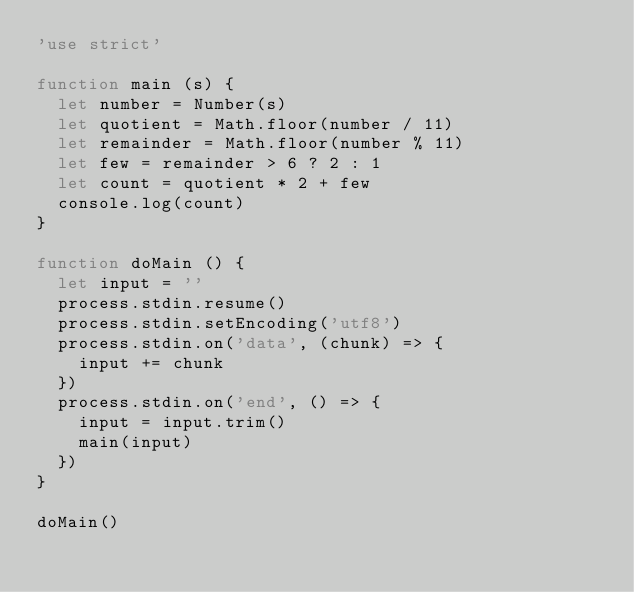Convert code to text. <code><loc_0><loc_0><loc_500><loc_500><_JavaScript_>'use strict'

function main (s) {
  let number = Number(s)
  let quotient = Math.floor(number / 11)
  let remainder = Math.floor(number % 11)
  let few = remainder > 6 ? 2 : 1
  let count = quotient * 2 + few
  console.log(count)
}

function doMain () {
  let input = ''
  process.stdin.resume()
  process.stdin.setEncoding('utf8')
  process.stdin.on('data', (chunk) => {
    input += chunk
  })
  process.stdin.on('end', () => {
    input = input.trim()
    main(input)
  })
}

doMain()
</code> 